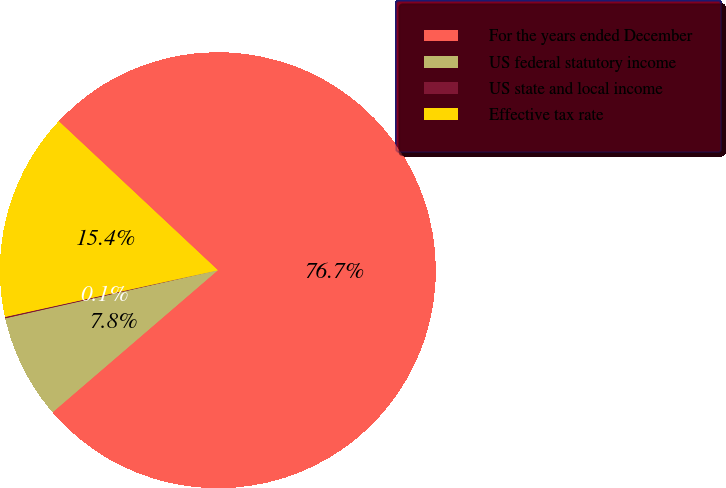Convert chart to OTSL. <chart><loc_0><loc_0><loc_500><loc_500><pie_chart><fcel>For the years ended December<fcel>US federal statutory income<fcel>US state and local income<fcel>Effective tax rate<nl><fcel>76.73%<fcel>7.76%<fcel>0.1%<fcel>15.42%<nl></chart> 